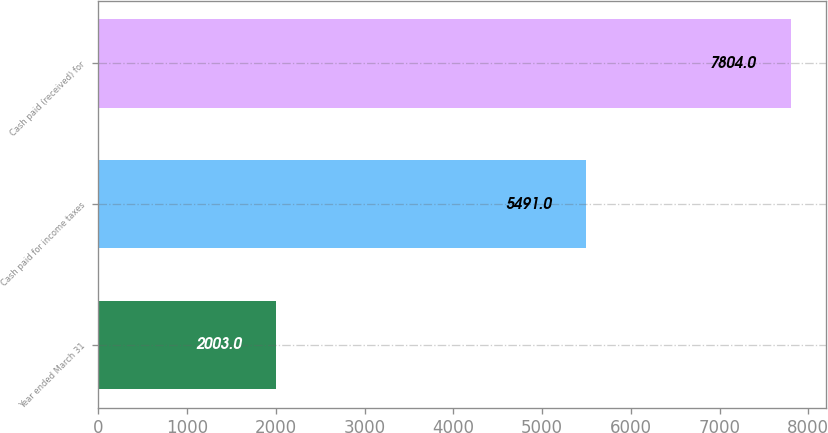<chart> <loc_0><loc_0><loc_500><loc_500><bar_chart><fcel>Year ended March 31<fcel>Cash paid for income taxes<fcel>Cash paid (received) for<nl><fcel>2003<fcel>5491<fcel>7804<nl></chart> 